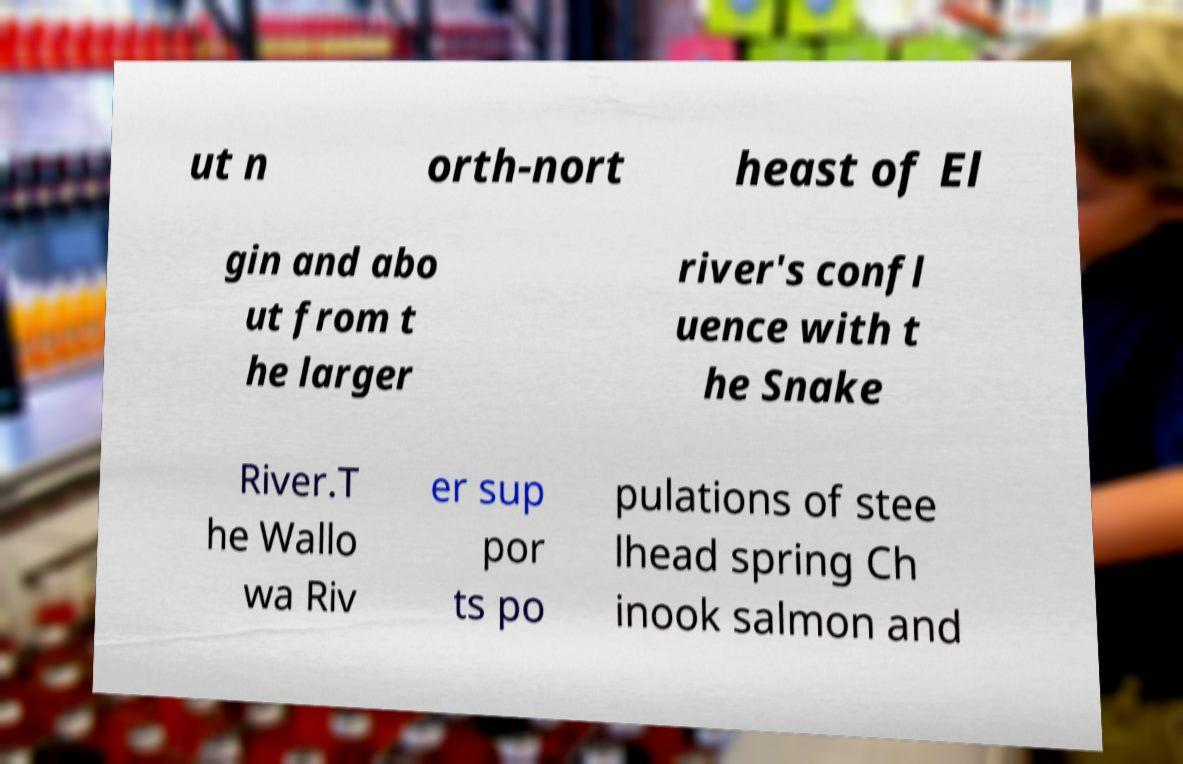What messages or text are displayed in this image? I need them in a readable, typed format. ut n orth-nort heast of El gin and abo ut from t he larger river's confl uence with t he Snake River.T he Wallo wa Riv er sup por ts po pulations of stee lhead spring Ch inook salmon and 